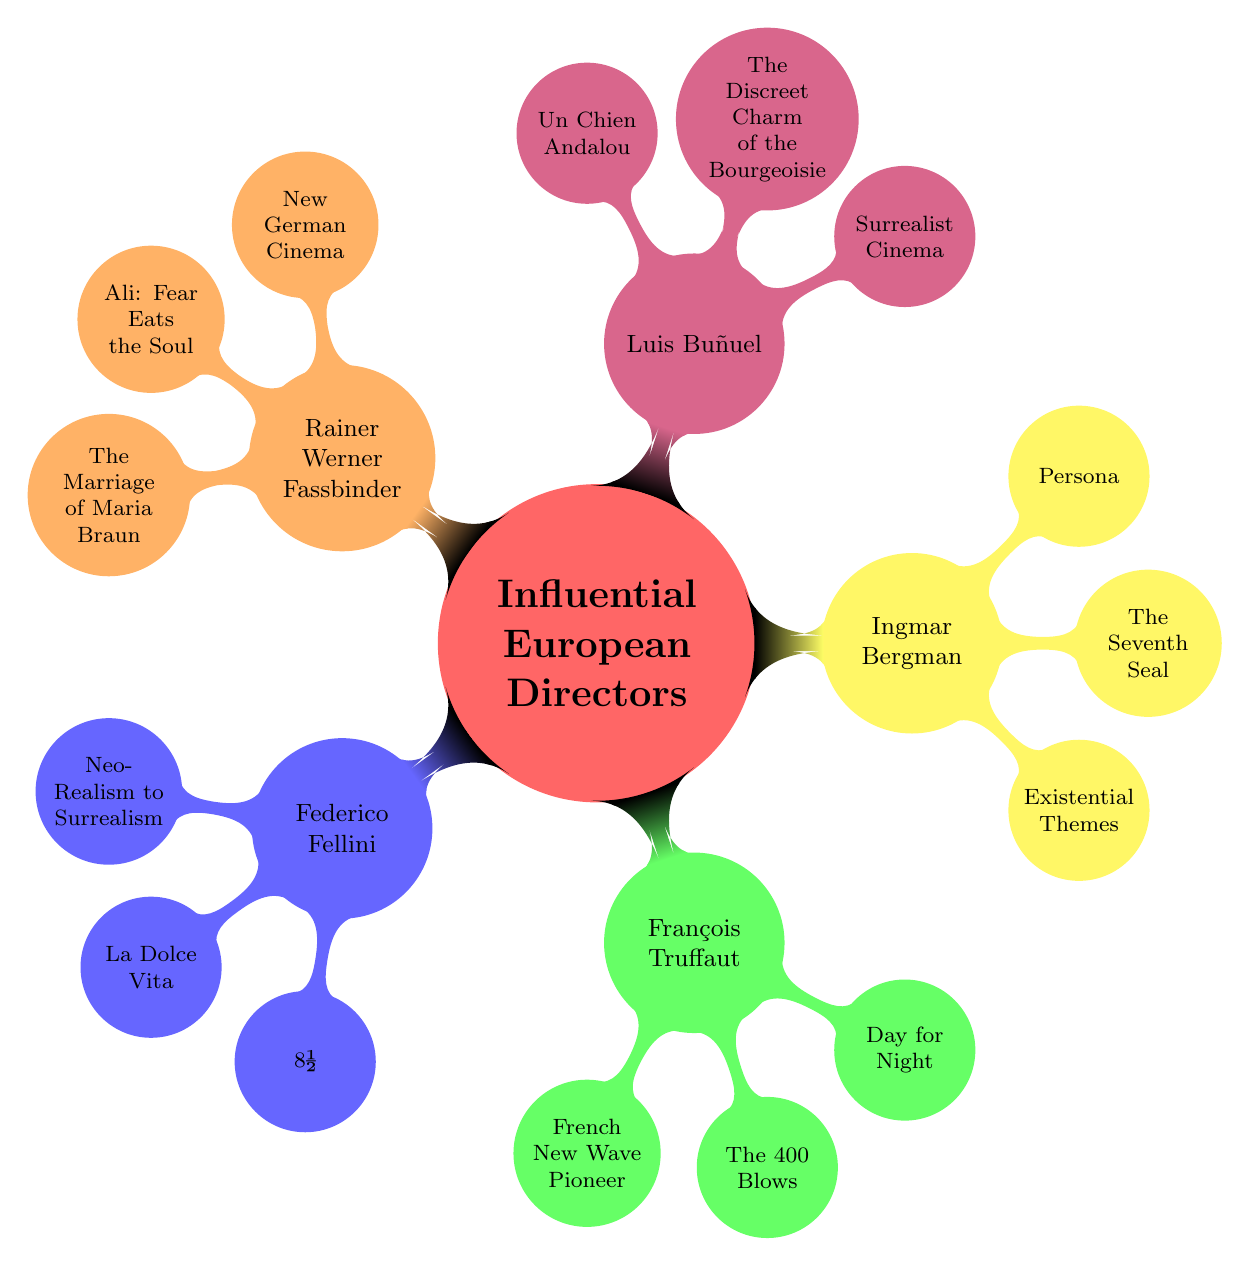What are the contributions of Federico Fellini? The diagram shows three contributions listed under Federico Fellini: "Neo-Realism to Surrealism," "La Dolce Vita," and "8½." The question directly refers to the child's information linked to his node.
Answer: Neo-Realism to Surrealism, La Dolce Vita, 8½ Which director is a pioneer of the French New Wave? In the diagram, François Truffaut is specifically identified as the "French New Wave Pioneer." This is directly stated under his node as part of his contributions.
Answer: François Truffaut How many contributions does Ingmar Bergman have listed? Looking at Ingmar Bergman's node, it states three contributions: "Existential Themes," "The Seventh Seal," and "Persona." Counting these gives a total of three contributions.
Answer: 3 What type of cinema is Luis Buñuel known for? The diagram describes Luis Buñuel's contributions, one of which is "Surrealist Cinema." The answer is directly identified under his node.
Answer: Surrealist Cinema Which director's work includes "Ali: Fear Eats the Soul"? The diagram states that "Ali: Fear Eats the Soul" is one of the contributions of Rainer Werner Fassbinder, as noted under his node. Thus, we conclude it is linked to him.
Answer: Rainer Werner Fassbinder How many directors are mentioned in the diagram? The diagram lists five directors: Federico Fellini, François Truffaut, Ingmar Bergman, Luis Buñuel, and Rainer Werner Fassbinder. Counting these gives a total of five directors.
Answer: 5 What film is associated with existential themes as per the diagram? The diagram indicates that "The Seventh Seal" is listed under Ingmar Bergman’s contributions, which is associated with existential themes, establishing a direct connection between the two.
Answer: The Seventh Seal Which director’s contributions include "Un Chien Andalou"? In the diagram, "Un Chien Andalou" is explicitly listed under Luis Buñuel's contributions, linking the film directly to his body of work.
Answer: Luis Buñuel What movement is Rainer Werner Fassbinder associated with? The diagram states that Rainer Werner Fassbinder is linked with "New German Cinema," which is one of the contributions listed under his node, defining his movement.
Answer: New German Cinema 